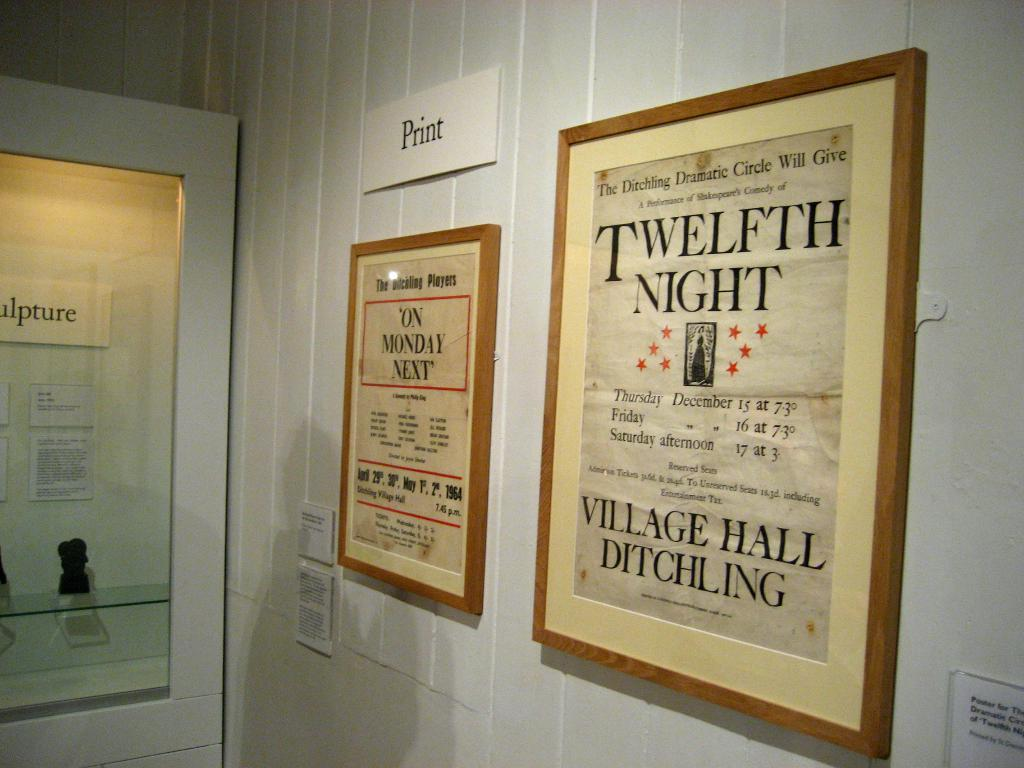<image>
Write a terse but informative summary of the picture. A poster hanging on the wall advertising Shakespeare's Twelfth Night. 